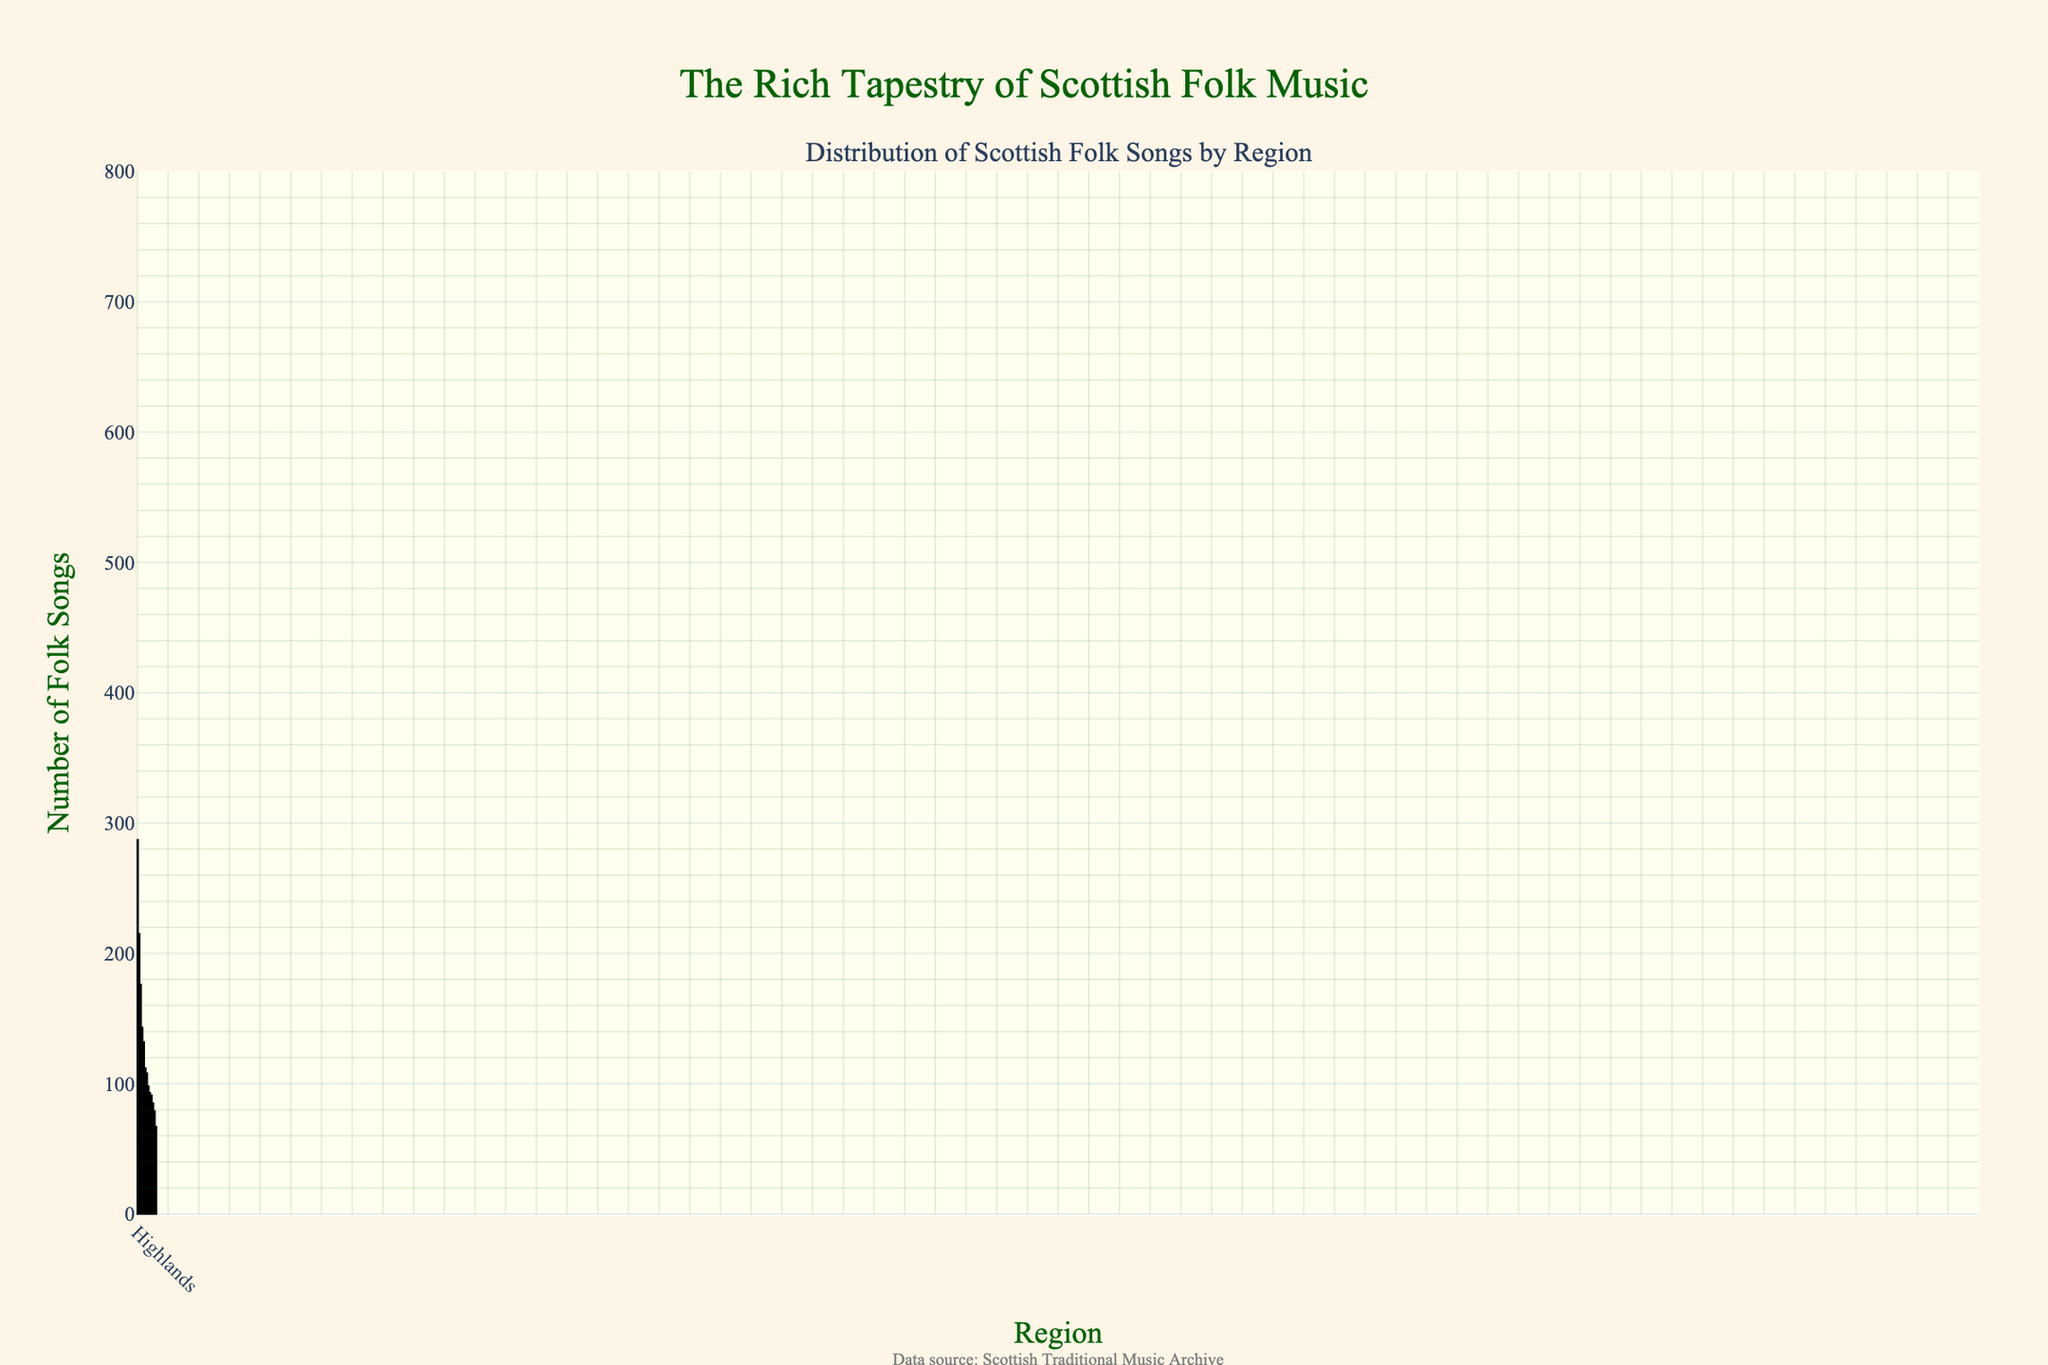what is the region with the highest number of folk songs? The figure shows a bar chart with various regions and the number of folk songs in each. By observing the heights of the bars, the Highland region has the tallest bar, indicating the highest number of folk songs.
Answer: Highlands how many more folk songs are there in the Western Isles compared to Dumfries and Galloway? To find the difference in the number of folk songs between the Western Isles and Dumfries and Galloway, subtract the number of folk songs in Dumfries and Galloway (67) from the number in the Western Isles (176). The calculation is 176 - 67.
Answer: 109 which regions have fewer than 100 folk songs? By observing the bars that do not reach the 100 mark on the y-axis, the regions with fewer than 100 folk songs are Borders (98), Fife (85), Tayside (91), Central Scotland (79), Dumfries and Galloway (67), and Lothian (93).
Answer: Borders, Fife, Tayside, Central Scotland, Dumfries and Galloway, Lothian what is the total number of folk songs in the top three regions? First, identify the top three regions by the height of their bars, which are Highlands, Lowlands, and Orkney and Shetland. Add their number of folk songs: 287 (Highlands) + 215 (Lowlands) + 143 (Orkney and Shetland). The sum is 287 + 215 + 143.
Answer: 645 is the number of folk songs in Strathclyde greater than the number in Grampian? By comparing the heights of the bars for Strathclyde and Grampian, Strathclyde has 132 folk songs, while Grampian has 108. Since 132 is greater than 108, Strathclyde has more folk songs.
Answer: Yes which region has the closest number of folk songs to Tayside? Tayside has 91 folk songs. The region with the closest number is Lothian with 93 folk songs, as it is the region with a bar height nearest to that of Tayside.
Answer: Lothian what is the median number of folk songs across all regions? First, list the number of folk songs in ascending order: 67, 79, 85, 91, 93, 98, 108, 112, 132, 143, 176, 215, 287. Since there are 13 data points, the median is the middle value, which is the 7th value in the sorted list.
Answer: 108 compare the combined number of folk songs in Lowlands and Western Isles to Highlands. Which is larger? Sum the number of folk songs in Lowlands (215) and Western Isles (176), which equals 391. Compare this sum to the number of folk songs in Highlands (287). Since 391 is greater than 287, the combined total of Lowlands and Western Isles is larger.
Answer: Lowlands and Western Isles which region has the second least number of folk songs? The region with the least number of folk songs is Dumfries and Galloway with 67 folk songs. The second lowest is Central Scotland with 79 folk songs.
Answer: Central Scotland 